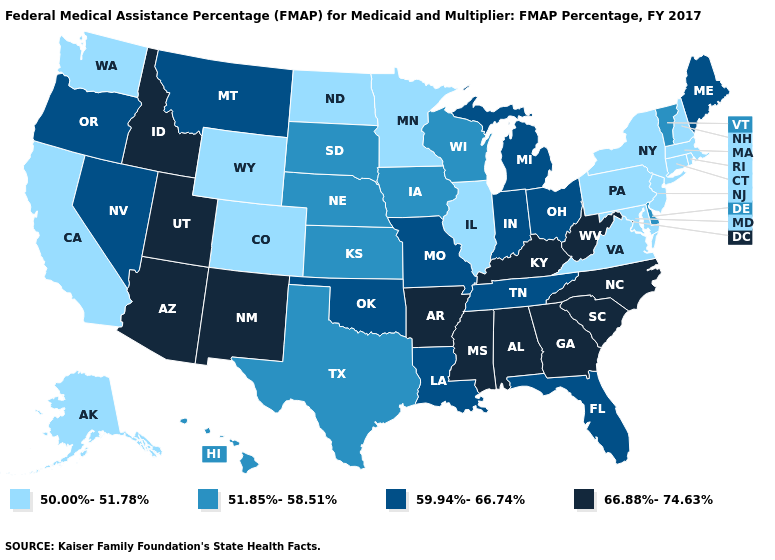Does South Carolina have the highest value in the USA?
Keep it brief. Yes. What is the highest value in states that border Minnesota?
Answer briefly. 51.85%-58.51%. What is the value of Rhode Island?
Answer briefly. 50.00%-51.78%. Among the states that border Tennessee , does Georgia have the highest value?
Answer briefly. Yes. Does Alabama have the lowest value in the USA?
Short answer required. No. What is the value of Kentucky?
Write a very short answer. 66.88%-74.63%. What is the value of Mississippi?
Be succinct. 66.88%-74.63%. Which states have the lowest value in the USA?
Keep it brief. Alaska, California, Colorado, Connecticut, Illinois, Maryland, Massachusetts, Minnesota, New Hampshire, New Jersey, New York, North Dakota, Pennsylvania, Rhode Island, Virginia, Washington, Wyoming. Among the states that border North Dakota , does Minnesota have the lowest value?
Quick response, please. Yes. Name the states that have a value in the range 50.00%-51.78%?
Short answer required. Alaska, California, Colorado, Connecticut, Illinois, Maryland, Massachusetts, Minnesota, New Hampshire, New Jersey, New York, North Dakota, Pennsylvania, Rhode Island, Virginia, Washington, Wyoming. Does West Virginia have the highest value in the USA?
Quick response, please. Yes. What is the value of Ohio?
Keep it brief. 59.94%-66.74%. Name the states that have a value in the range 50.00%-51.78%?
Give a very brief answer. Alaska, California, Colorado, Connecticut, Illinois, Maryland, Massachusetts, Minnesota, New Hampshire, New Jersey, New York, North Dakota, Pennsylvania, Rhode Island, Virginia, Washington, Wyoming. What is the value of Alabama?
Answer briefly. 66.88%-74.63%. 